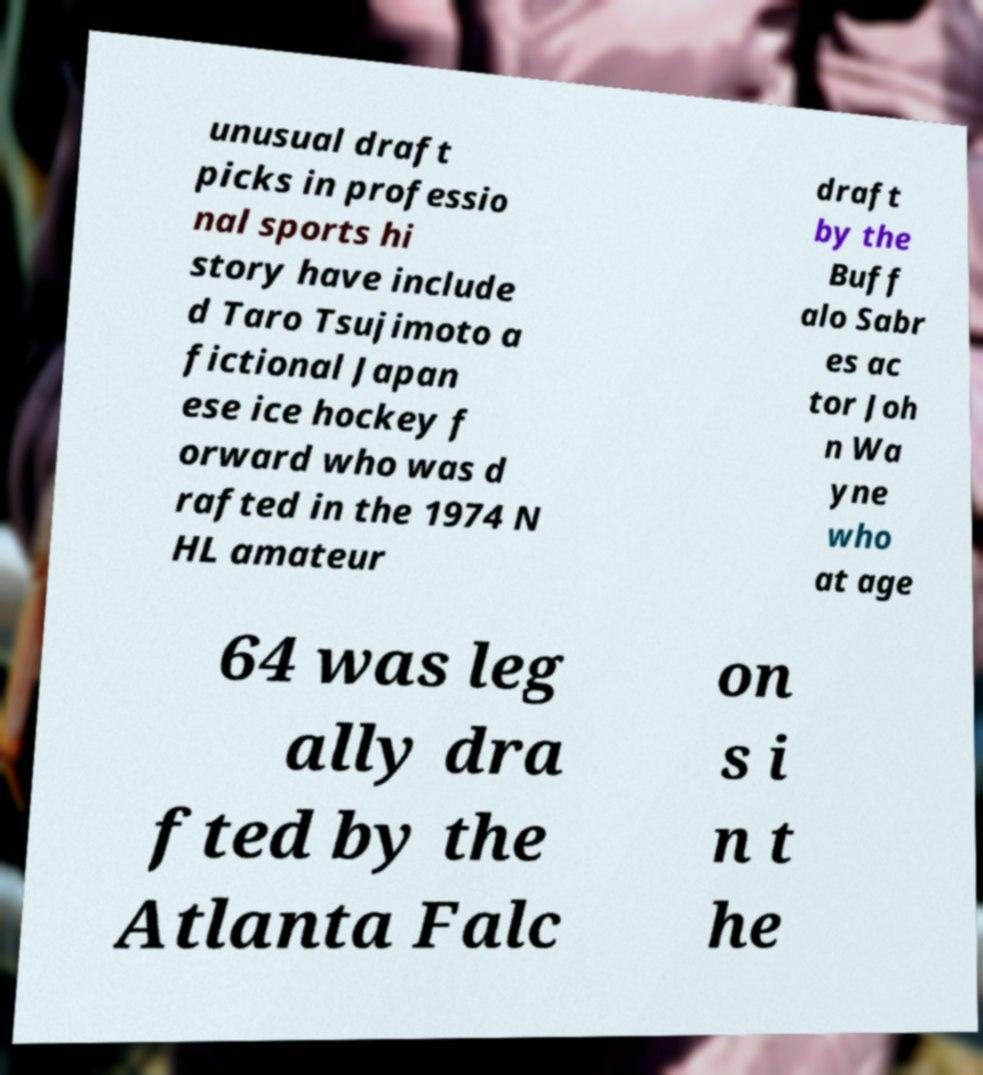Can you accurately transcribe the text from the provided image for me? unusual draft picks in professio nal sports hi story have include d Taro Tsujimoto a fictional Japan ese ice hockey f orward who was d rafted in the 1974 N HL amateur draft by the Buff alo Sabr es ac tor Joh n Wa yne who at age 64 was leg ally dra fted by the Atlanta Falc on s i n t he 